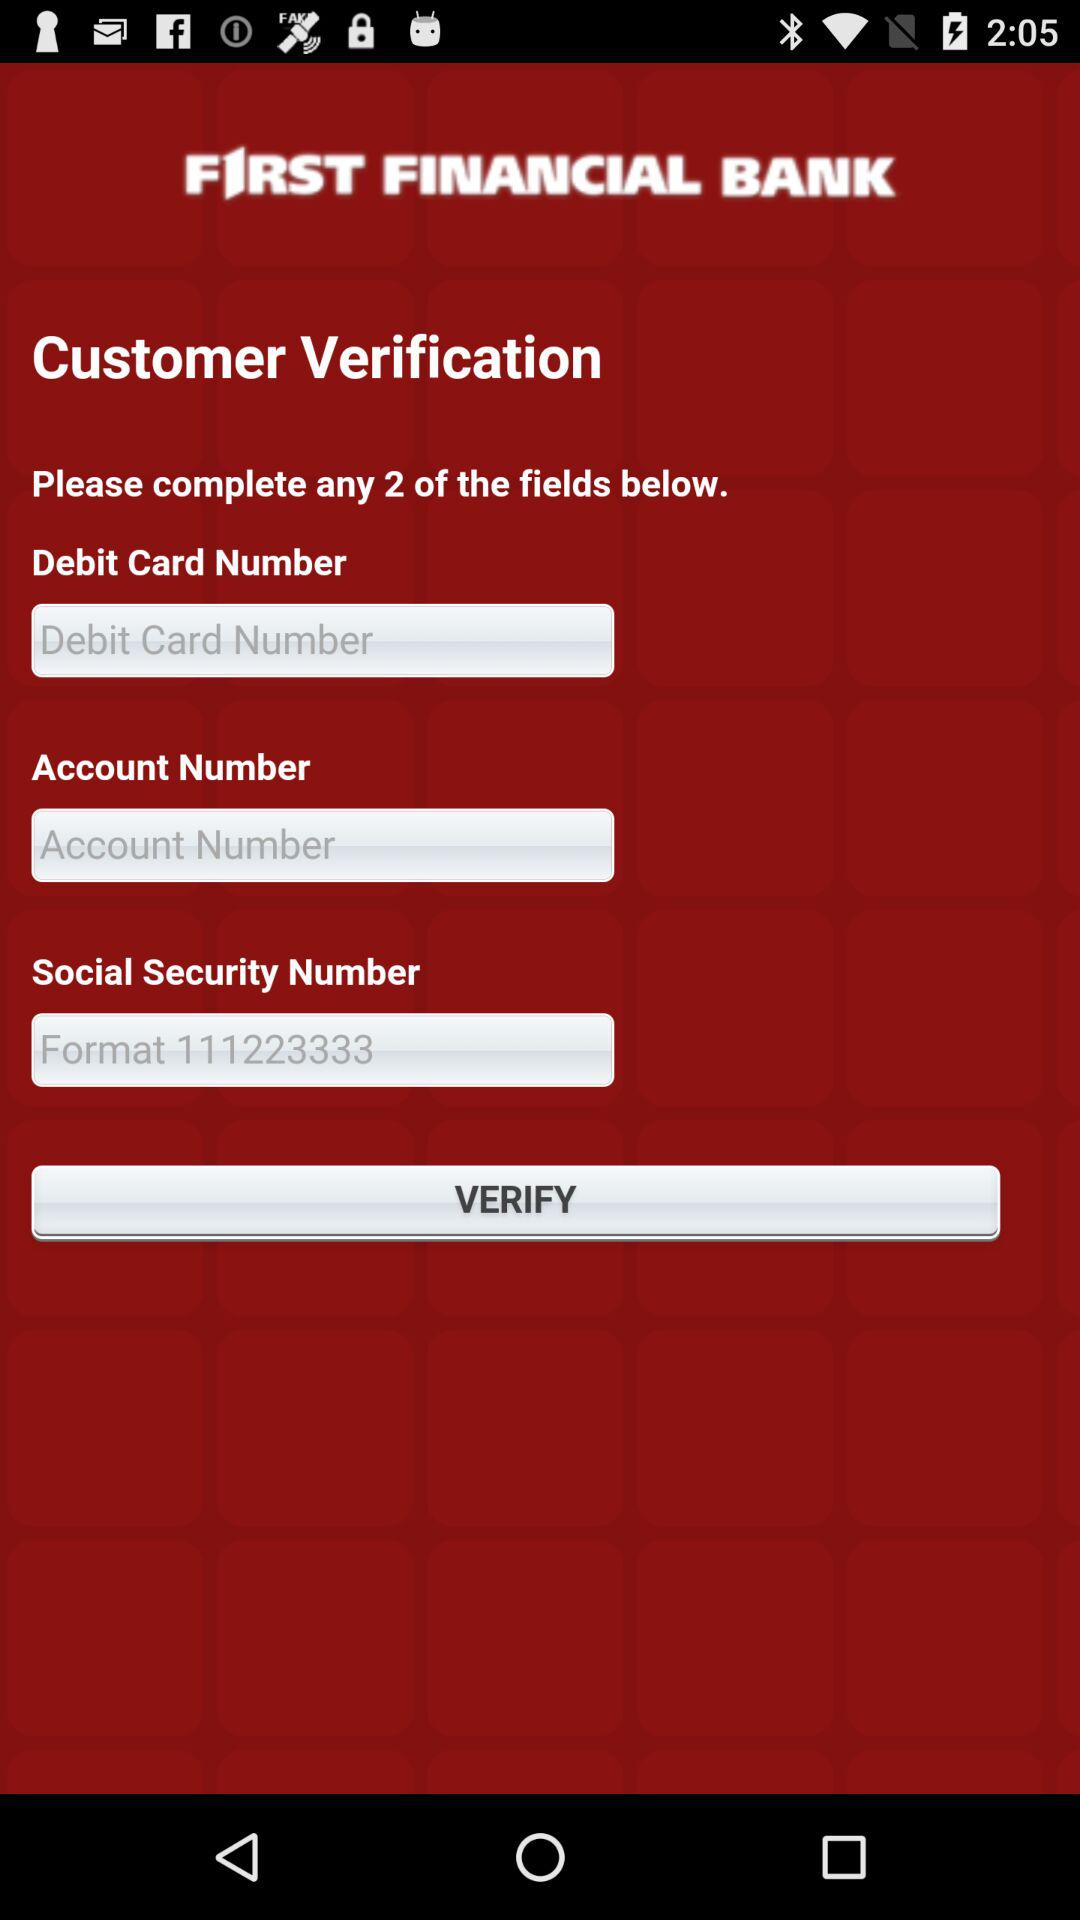How many fields have the text 'Format' in them?
Answer the question using a single word or phrase. 1 